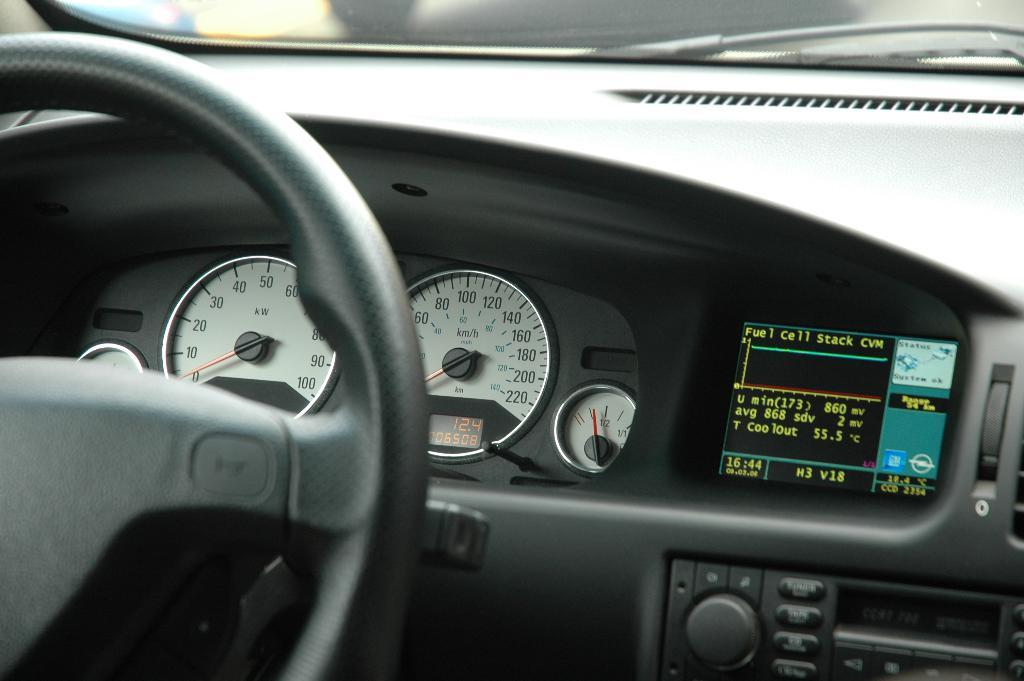What type of instrument is visible in the image? There is a speedometer in the image. What is used to control the direction of a vehicle in the image? There is a steering wheel in the image. What allows the driver to see the road ahead in the image? There is a windshield in the image. What device is present for clearing the windshield in the image? There is a wiper in the image. How many sheep can be seen grazing in the room in the image? There are no sheep or rooms present in the image; it features a speedometer, steering wheel, windshield, and wiper. What type of flower is blooming on the dashboard in the image? There are no flowers present in the image; it features a speedometer, steering wheel, windshield, and wiper. 